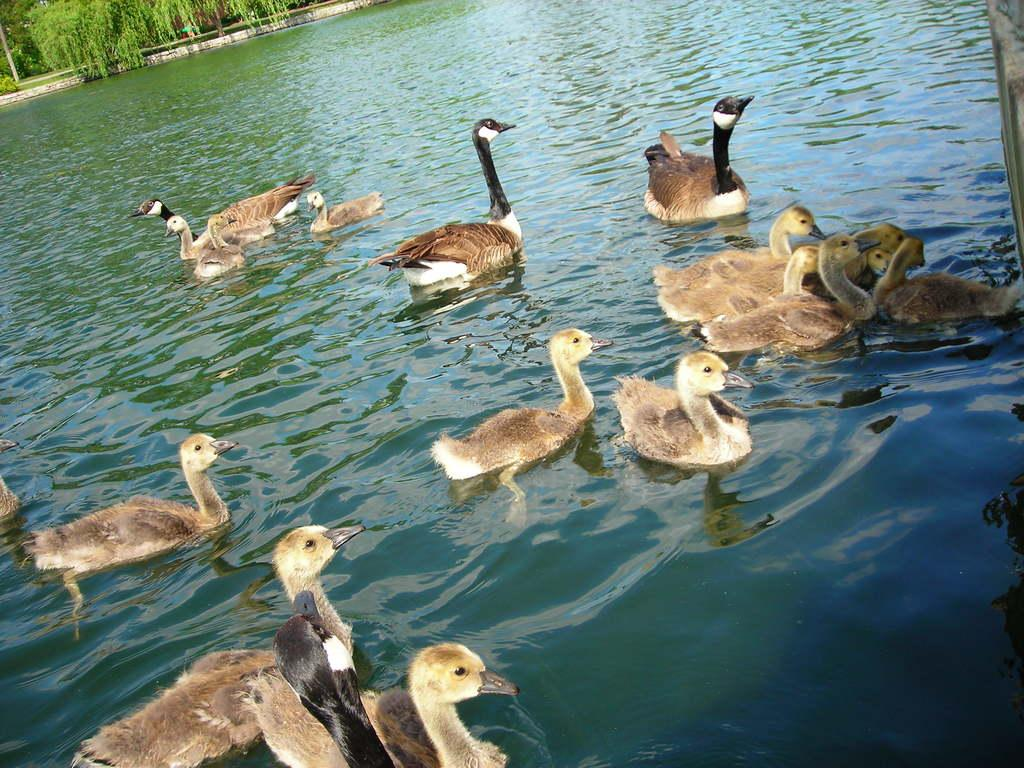What type of animals are in the center of the image? There are aquatic birds in the center of the image. Where are the birds located? The birds are in the water. What can be seen in the background of the image? There are trees in the background of the image. What is on the right side of the image? There is a wall on the right side of the image. What type of cactus can be seen providing pleasure to the birds in the image? There is no cactus present in the image, and the birds are not shown receiving pleasure from any object or activity. 